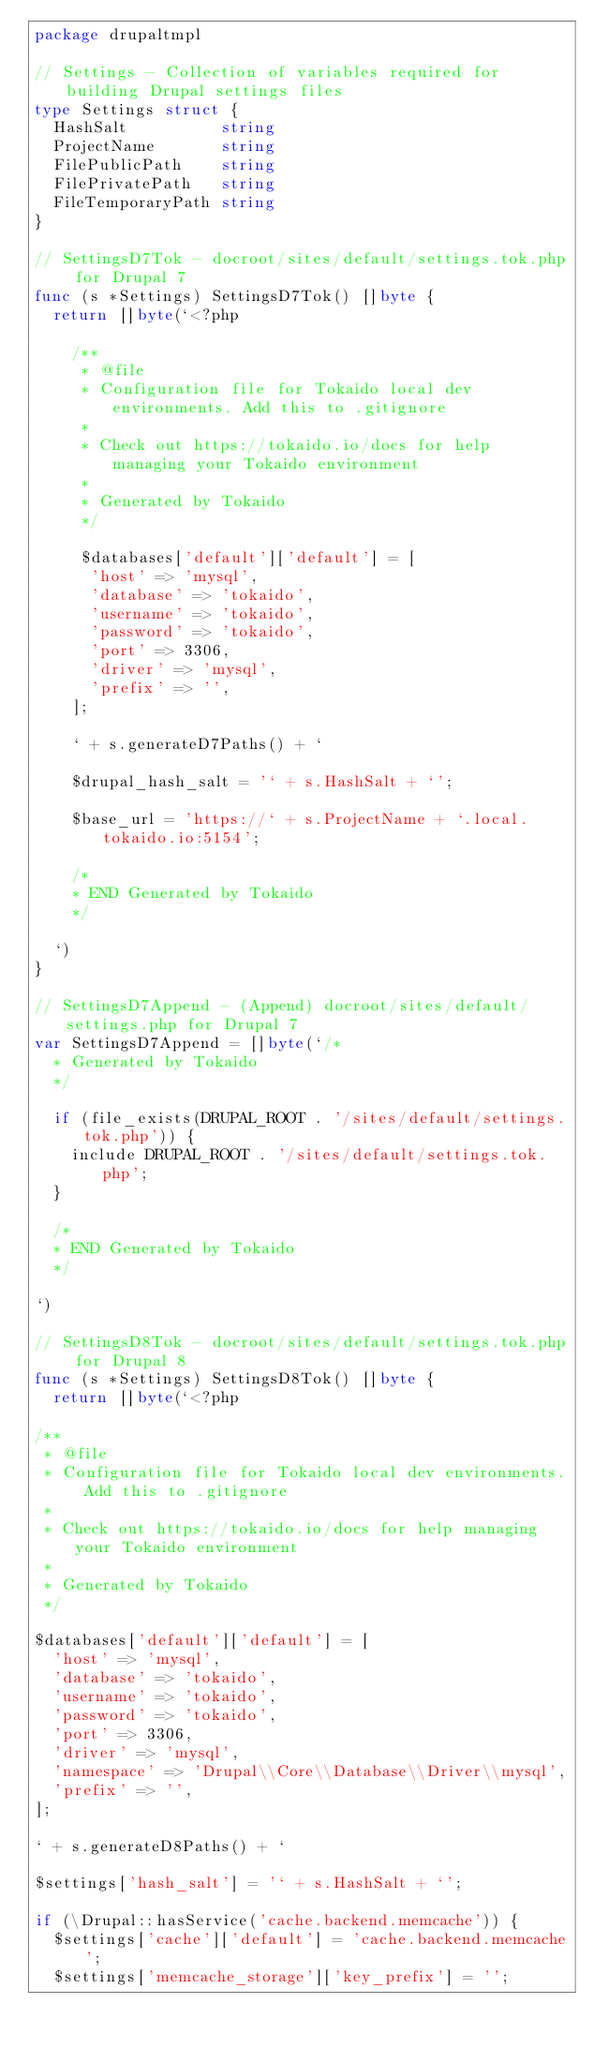<code> <loc_0><loc_0><loc_500><loc_500><_Go_>package drupaltmpl

// Settings - Collection of variables required for building Drupal settings files
type Settings struct {
	HashSalt          string
	ProjectName       string
	FilePublicPath    string
	FilePrivatePath   string
	FileTemporaryPath string
}

// SettingsD7Tok - docroot/sites/default/settings.tok.php for Drupal 7
func (s *Settings) SettingsD7Tok() []byte {
	return []byte(`<?php

    /**
     * @file
     * Configuration file for Tokaido local dev environments. Add this to .gitignore
     *
     * Check out https://tokaido.io/docs for help managing your Tokaido environment
     *
     * Generated by Tokaido
     */

     $databases['default']['default'] = [
      'host' => 'mysql',
      'database' => 'tokaido',
      'username' => 'tokaido',
      'password' => 'tokaido',
      'port' => 3306,
      'driver' => 'mysql',
      'prefix' => '',
    ];

    ` + s.generateD7Paths() + `

    $drupal_hash_salt = '` + s.HashSalt + `';

    $base_url = 'https://` + s.ProjectName + `.local.tokaido.io:5154';

    /*
    * END Generated by Tokaido
    */

  `)
}

// SettingsD7Append - (Append) docroot/sites/default/settings.php for Drupal 7
var SettingsD7Append = []byte(`/*
  * Generated by Tokaido
  */

  if (file_exists(DRUPAL_ROOT . '/sites/default/settings.tok.php')) {
    include DRUPAL_ROOT . '/sites/default/settings.tok.php';
  }

  /*
  * END Generated by Tokaido
  */

`)

// SettingsD8Tok - docroot/sites/default/settings.tok.php for Drupal 8
func (s *Settings) SettingsD8Tok() []byte {
	return []byte(`<?php

/**
 * @file
 * Configuration file for Tokaido local dev environments. Add this to .gitignore
 *
 * Check out https://tokaido.io/docs for help managing your Tokaido environment
 *
 * Generated by Tokaido
 */

$databases['default']['default'] = [
  'host' => 'mysql',
  'database' => 'tokaido',
  'username' => 'tokaido',
  'password' => 'tokaido',
  'port' => 3306,
  'driver' => 'mysql',
  'namespace' => 'Drupal\\Core\\Database\\Driver\\mysql',
  'prefix' => '',
];

` + s.generateD8Paths() + `

$settings['hash_salt'] = '` + s.HashSalt + `';

if (\Drupal::hasService('cache.backend.memcache')) {
  $settings['cache']['default'] = 'cache.backend.memcache';
  $settings['memcache_storage']['key_prefix'] = '';</code> 